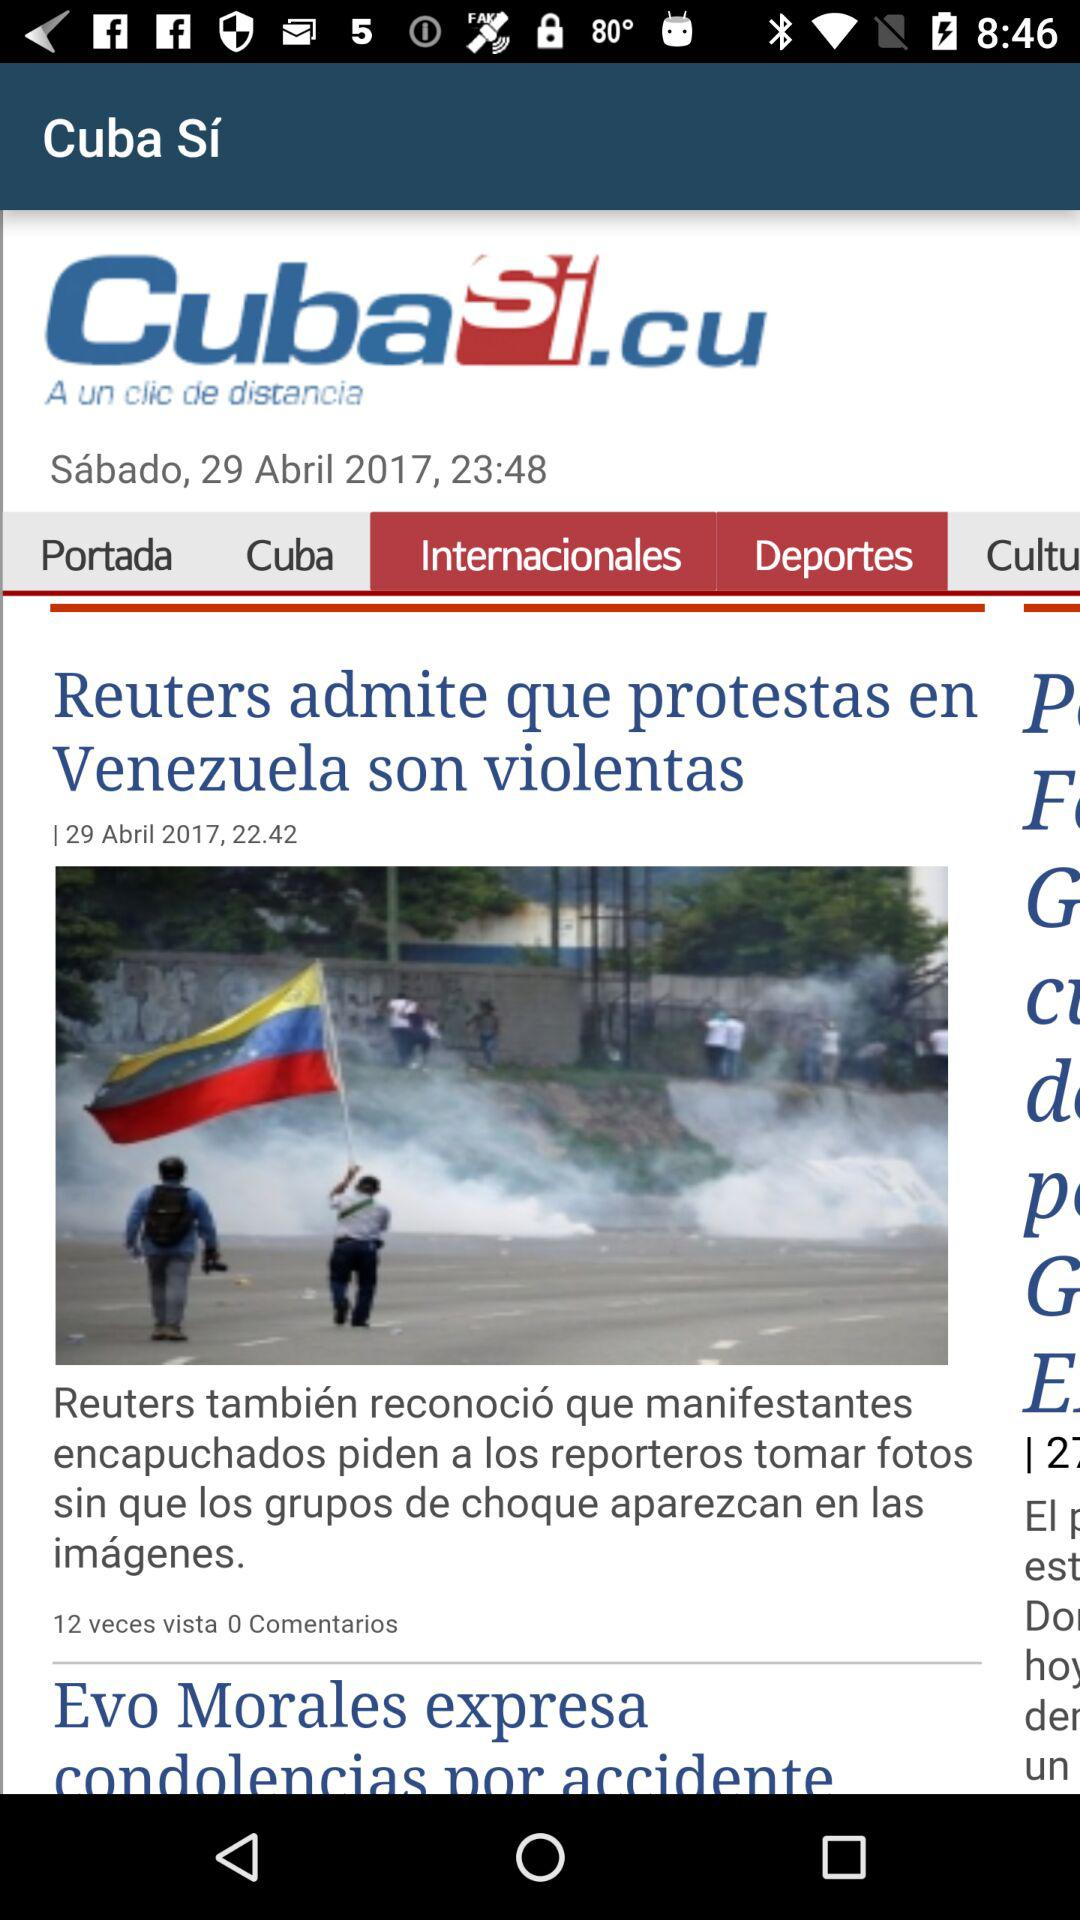How many more times has the article been viewed than commented on?
Answer the question using a single word or phrase. 12 